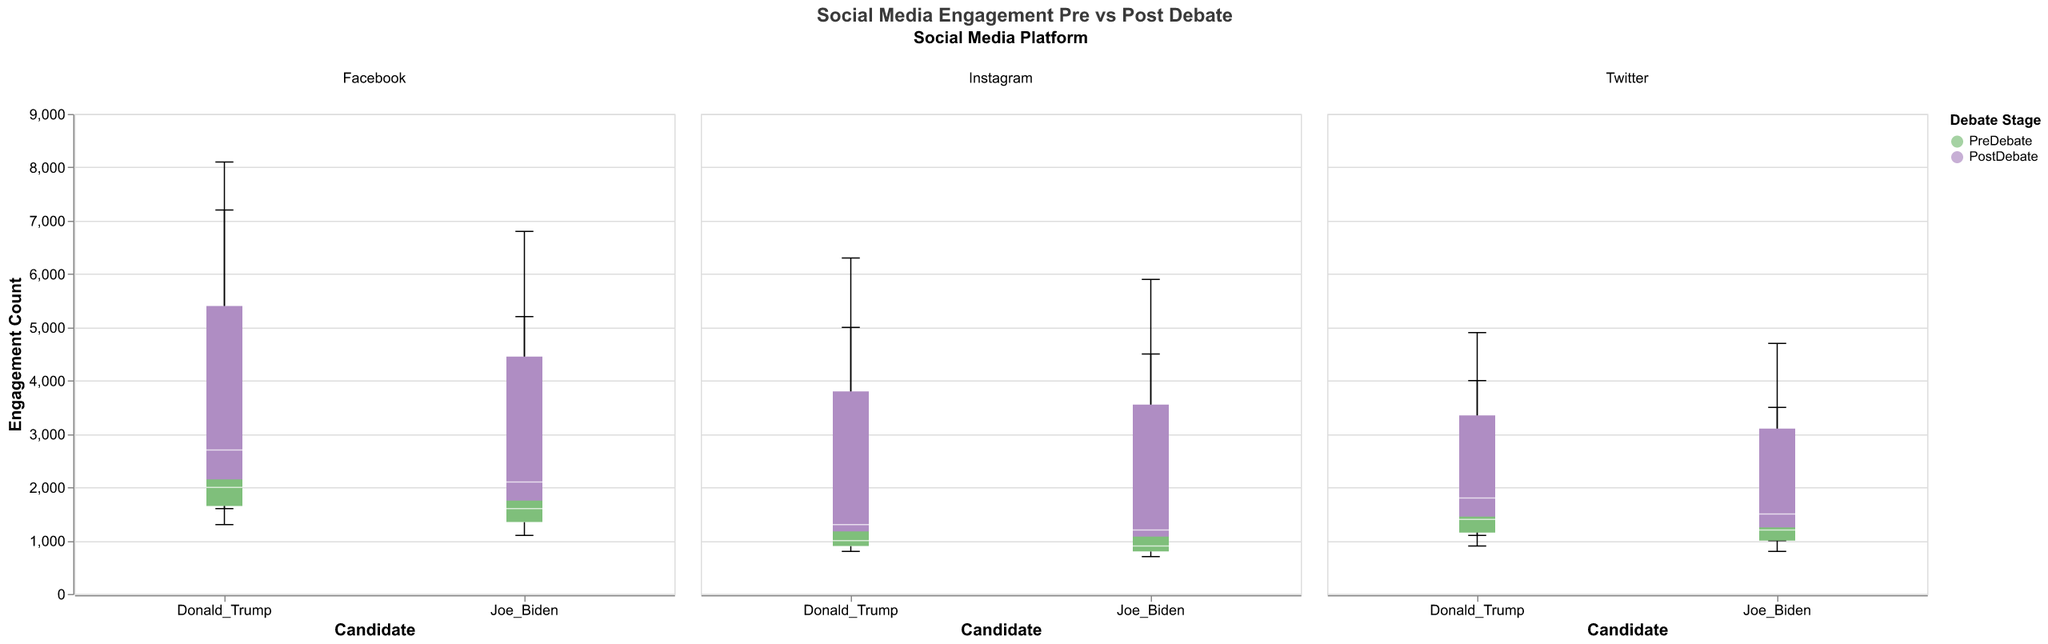What's the title of the figure? The title is found at the top of the figure and it summarizes the content of the plot. The title of the figure is "Social Media Engagement Pre vs Post Debate".
Answer: Social Media Engagement Pre vs Post Debate Which candidate had higher post-debate likes on Instagram? To answer this, we need to examine the post-debate likes for Joe Biden and Donald Trump on Instagram. Joe Biden had 5900 likes, while Donald Trump had 6300 likes. Donald Trump had higher post-debate likes on Instagram.
Answer: Donald Trump What is the color representing post-debate data? The legend on the figure indicates which colors correspond to pre-debate and post-debate data. According to the legend, the color for post-debate data is purple.
Answer: Purple How did Joe Biden's Facebook shares change from pre-debate to post-debate? To determine the change, look at Joe Biden's shares on Facebook pre-debate and post-debate. Joe Biden had 1600 shares pre-debate and 2100 shares post-debate. Subtract the pre-debate value from the post-debate value (2100 - 1600).
Answer: Increased by 500 Which platform shows the highest post-debate engagement for Donald Trump? To find this, compare Donald Trump's post-debate engagement values (likes, shares, comments) across all platforms. The highest value will be on Facebook with 8100 likes.
Answer: Facebook What are the median engagement counts for Joe Biden on Twitter pre-debate? The median value in a box plot is marked by the white line within the box. For Joe Biden on Twitter pre-debate, examine the median line within the corresponding box plot for engagement types (likes, shares, comments).
Answer: Likes: 3500, Shares: 1200, Comments: 800 Compare Joe Biden's and Donald Trump's changes in Facebook likes from pre-debate to post-debate. Joe Biden's Facebook likes increased from 5200 to 6800, while Donald Trump's Facebook likes increased from 7200 to 8100. Calculate the changes (6800-5200 for Joe Biden and 8100-7200 for Donald Trump). Joe Biden's likes increased by 1600, and Donald Trump's likes increased by 900. Joe Biden had a larger increase.
Answer: Joe Biden had a larger increase Which interaction type had the least engagement for Joe Biden pre-debate on Instagram? To determine this, compare Joe Biden's pre-debate engagement values for likes, shares, and comments on Instagram. The lowest value is 700 for comments.
Answer: Comments Summarize the change in interactions for both candidates post-debate on Twitter. Look at the changes in likes, shares, and comments for both Joe Biden and Donald Trump. Joe Biden: Likes increased by 1200, Shares increased by 300, Comments increased by 200. Donald Trump: Likes increased by 900, Shares increased by 400, Comments increased by 200. Consolidate these insights.
Answer: Likes and shares increased for both, comments increased slightly How do the engagement counts for Joe Biden compare across platforms post-debate? Compare Joe Biden’s post-debate engagement counts for all interaction types across Twitter, Facebook, and Instagram. Extract the counts and determine the range.
Answer: Twitter: Likes 4700, Shares 1500, Comments 1000; Facebook: Likes 6800, Shares 2100, Comments 1400; Instagram: Likes 5900, Shares 1200, Comments 950. Facebook has the highest engagements 